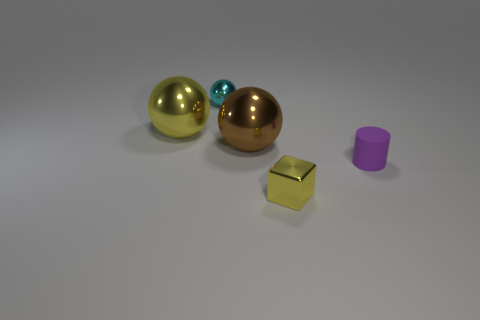Add 1 big yellow metal balls. How many objects exist? 6 Subtract all blocks. How many objects are left? 4 Add 1 brown spheres. How many brown spheres are left? 2 Add 4 tiny yellow cubes. How many tiny yellow cubes exist? 5 Subtract 0 yellow cylinders. How many objects are left? 5 Subtract all large metal balls. Subtract all tiny objects. How many objects are left? 0 